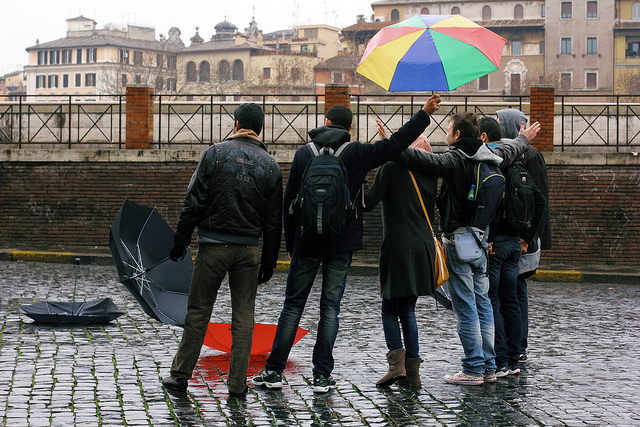How many backpacks can be seen? There are three backpacks visible in the image, carried by individuals who seem to be amidst a rainy outdoor setting, showcasing a candid moment of their urban experience. 